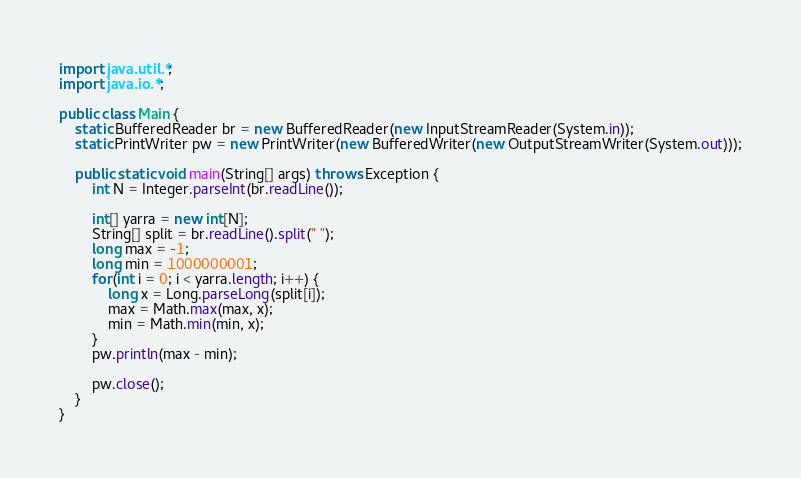Convert code to text. <code><loc_0><loc_0><loc_500><loc_500><_Java_>import java.util.*;
import java.io.*;

public class Main {
	static BufferedReader br = new BufferedReader(new InputStreamReader(System.in));
	static PrintWriter pw = new PrintWriter(new BufferedWriter(new OutputStreamWriter(System.out)));
	
	public static void main(String[] args) throws Exception {
		int N = Integer.parseInt(br.readLine());
		
		int[] yarra = new int[N];
		String[] split = br.readLine().split(" ");
		long max = -1;
		long min = 1000000001;
		for(int i = 0; i < yarra.length; i++) {
			long x = Long.parseLong(split[i]);
			max = Math.max(max, x);
			min = Math.min(min, x);
		}
		pw.println(max - min);
		
		pw.close();
	}
}</code> 